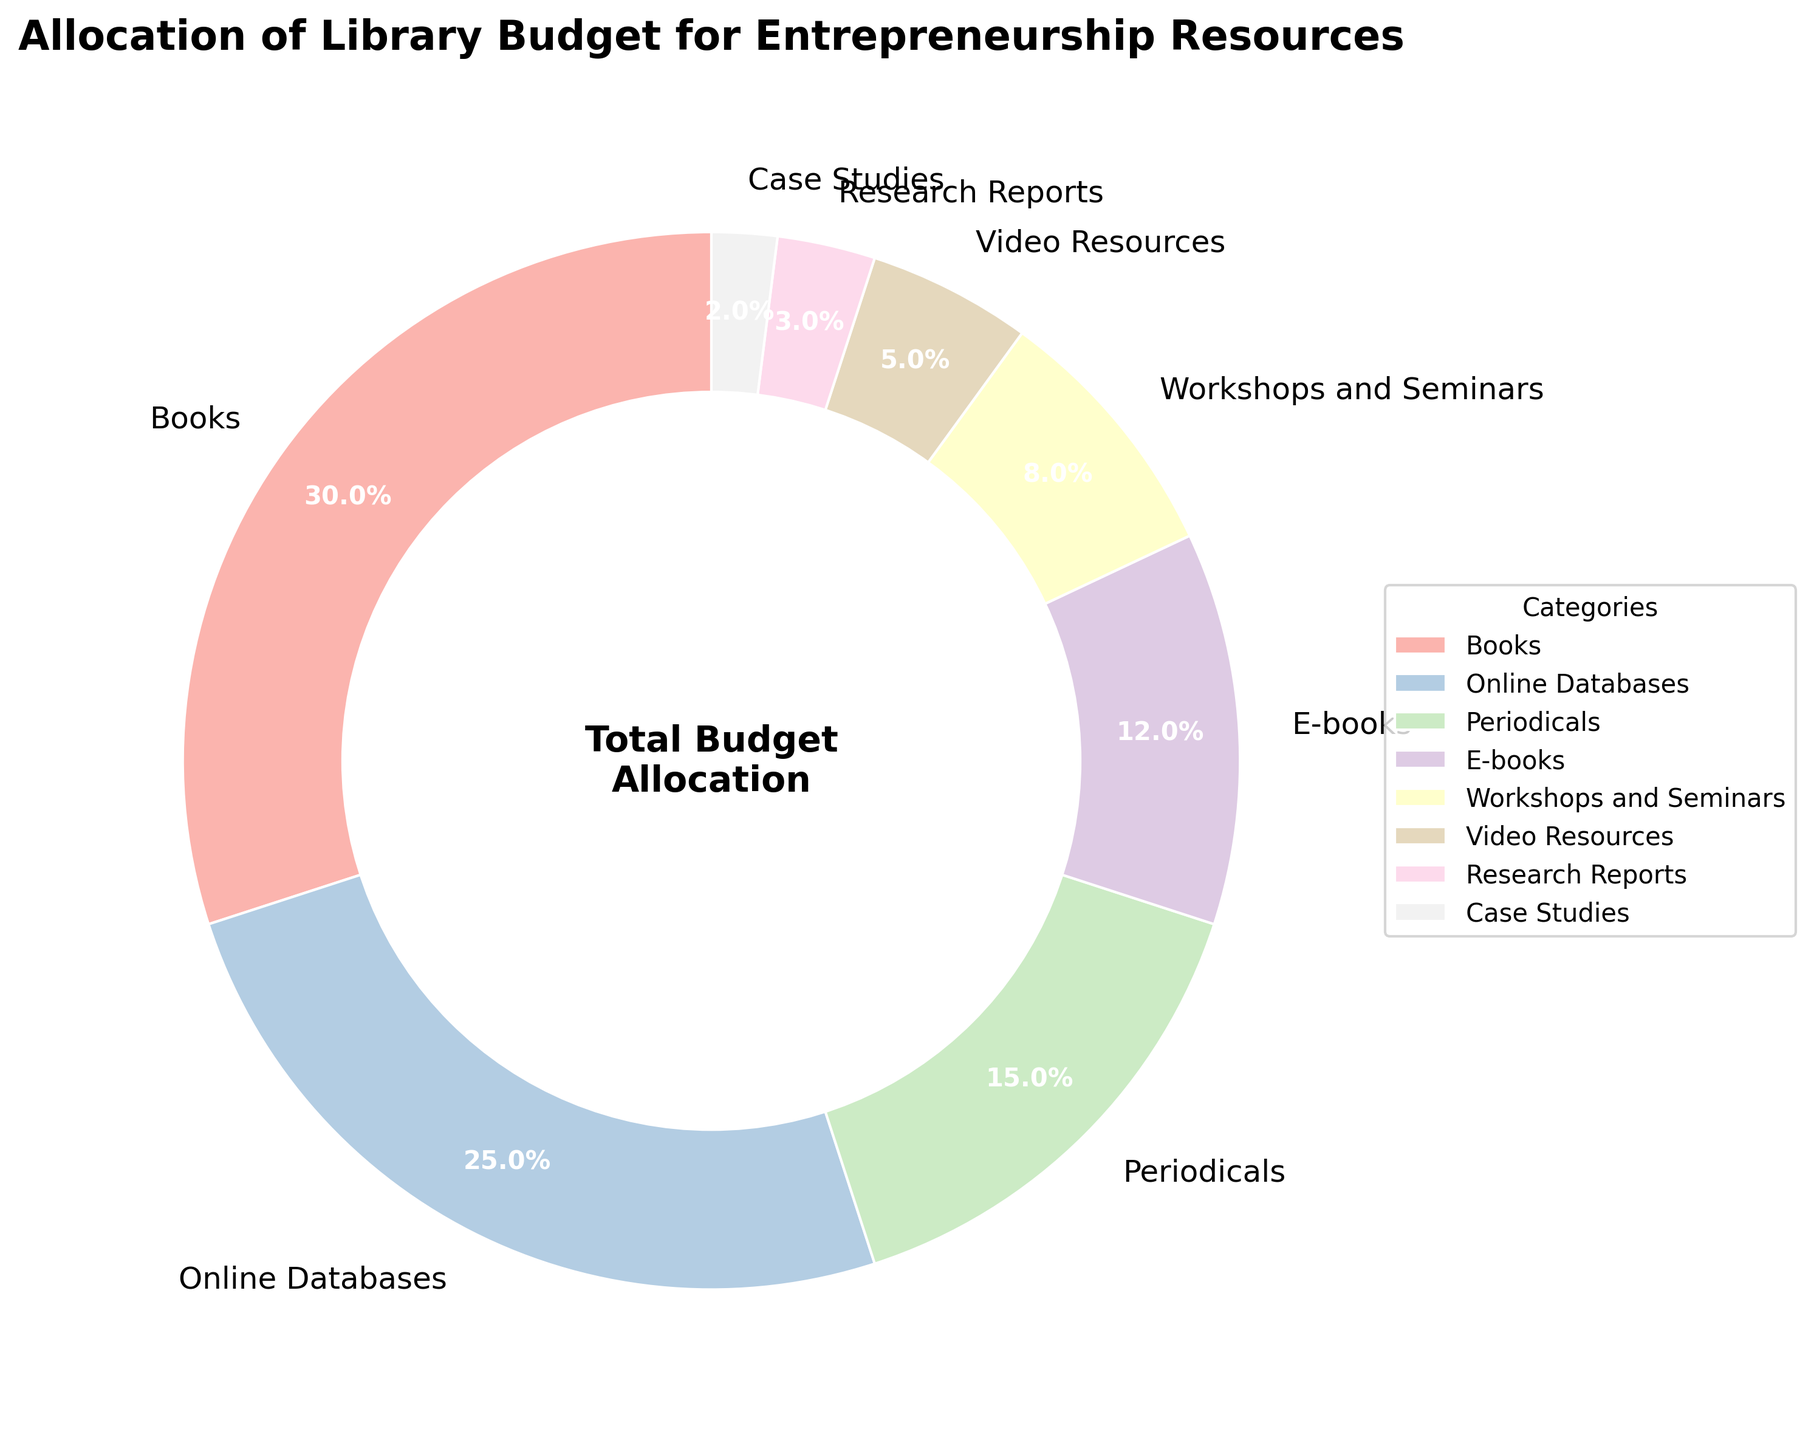What's the largest budget allocation category? Look at the category with the biggest slice in the pie chart. The largest slice, representing the highest budget percentage, is for "Books".
Answer: Books Which two categories combined make up half of the total budget? Add the percentages of the first two largest categories. Books have 30% and Online Databases have 25%. So, 30% + 25% = 55%, which is more than half of the total budget.
Answer: Books and Online Databases How much more budget percentage is allocated to Periodicals compared to Case Studies? Find the difference between the budget percentages of Periodicals and Case Studies. Periodicals have 15% and Case Studies have 2%. So, 15% - 2% = 13%.
Answer: 13% What is the total budget percentage allocated to E-books, Workshops and Seminars, and Video Resources combined? Add the percentages for E-books (12%), Workshops and Seminars (8%), and Video Resources (5%). So, 12% + 8% + 5% = 25%.
Answer: 25% Which category receives the least budget allocation? Identify the category with the smallest slice in the pie chart. The smallest slice is for "Case Studies" with 2%.
Answer: Case Studies What fraction of the budget is allocated to categories other than Books and Online Databases? Subtract the percentages of Books and Online Databases from 100%. Books have 30% and Online Databases have 25%. So, 100% - (30% + 25%) = 45%.
Answer: 45% If you combine the budget percentages of Periodicals and E-books, is it greater than the budget for Online Databases? Add the percentages for Periodicals and E-books, then compare it with Online Databases. Periodicals have 15% and E-books have 12%, so 15% + 12% = 27%. Since Online Databases have 25%, 27% > 25%.
Answer: Yes How do Workshops and Seminars compare to E-books in budget allocation? Compare the percentage of Workshops and Seminars (8%) with that of E-books (12%). 8% is less than 12%.
Answer: Less than What percentage of the budget is allocated to resources other than the top three categories (Books, Online Databases, Periodicals)? Add the percentages of the remaining categories and distinct them from 100% - sum of top three categories. Top three categories add to 70% (30% Books + 25% Online Databases + 15% Periodicals), so 100% - 70% = 30%.
Answer: 30% For a new category to have a higher budget percentage than Video Resources, what minimum percentage should it have? The percentage needs to be greater than the current budget percentage for Video Resources, which is 5%.
Answer: Greater than 5% 